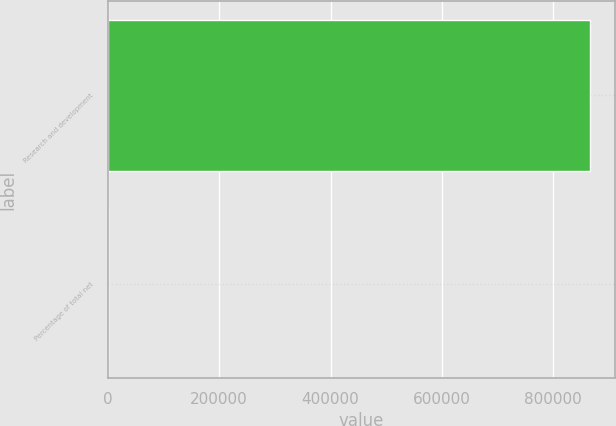<chart> <loc_0><loc_0><loc_500><loc_500><bar_chart><fcel>Research and development<fcel>Percentage of total net<nl><fcel>866882<fcel>17<nl></chart> 